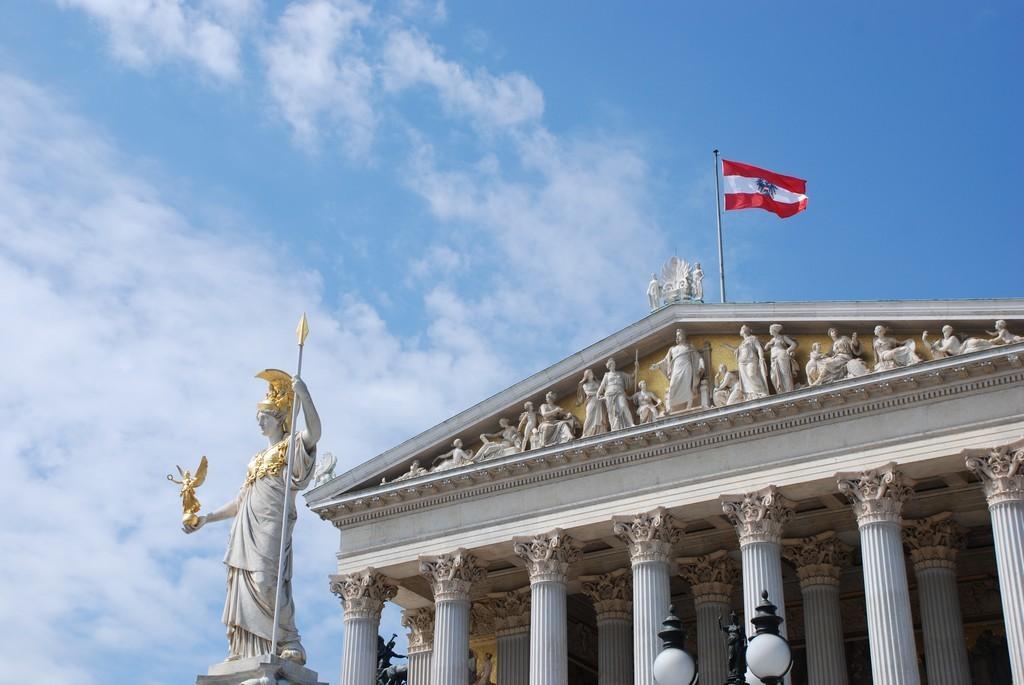In one or two sentences, can you explain what this image depicts? In this image we can see a building, there are some statues, pillars and lights, at the top of the building, we can see a flag and in the background we can see the sky with clouds. 